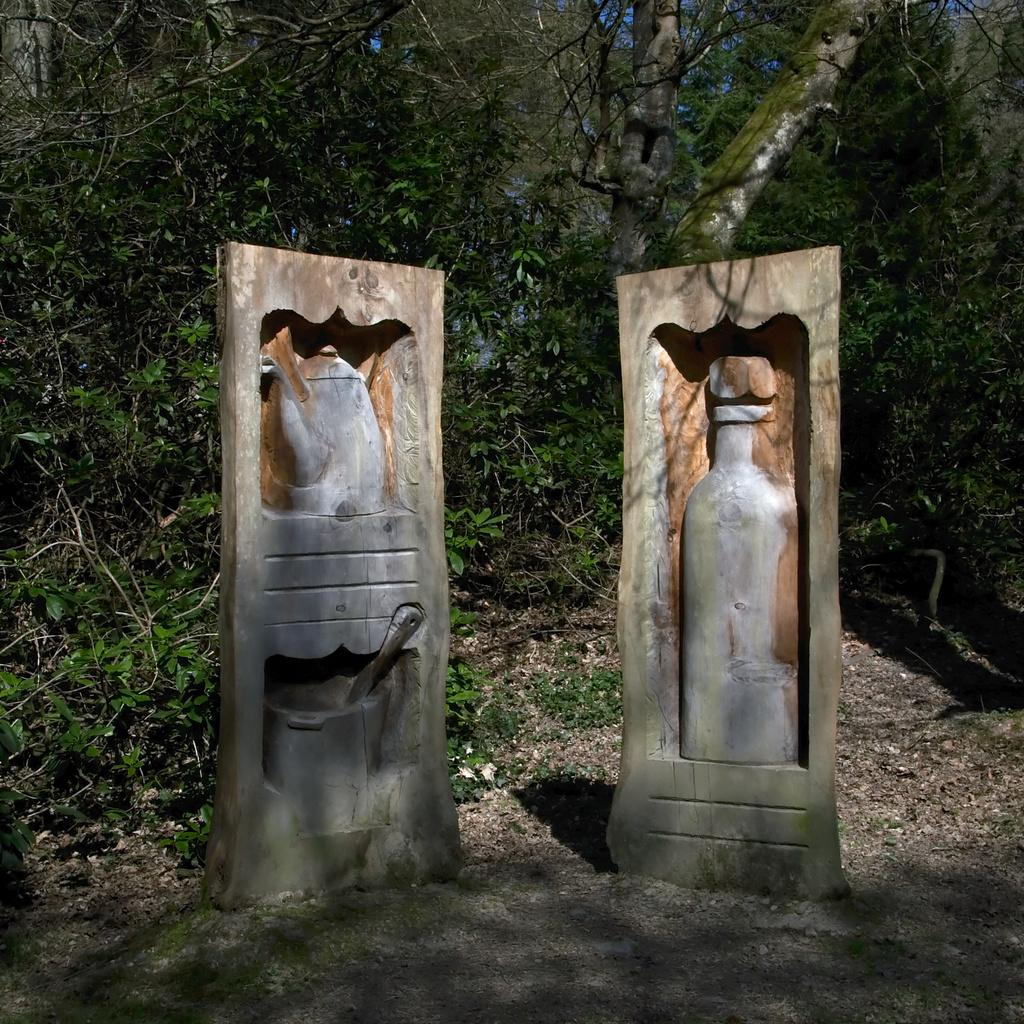What can be seen in the image that resembles art? There are two sculptures in the image. Where are the sculptures located? The sculptures are on a surface. What can be seen in the background of the image? There are plants and trees visible in the background of the image. What type of bells are hanging from the sculptures in the image? There are no bells present in the image; it only features two sculptures and a background with plants and trees. 